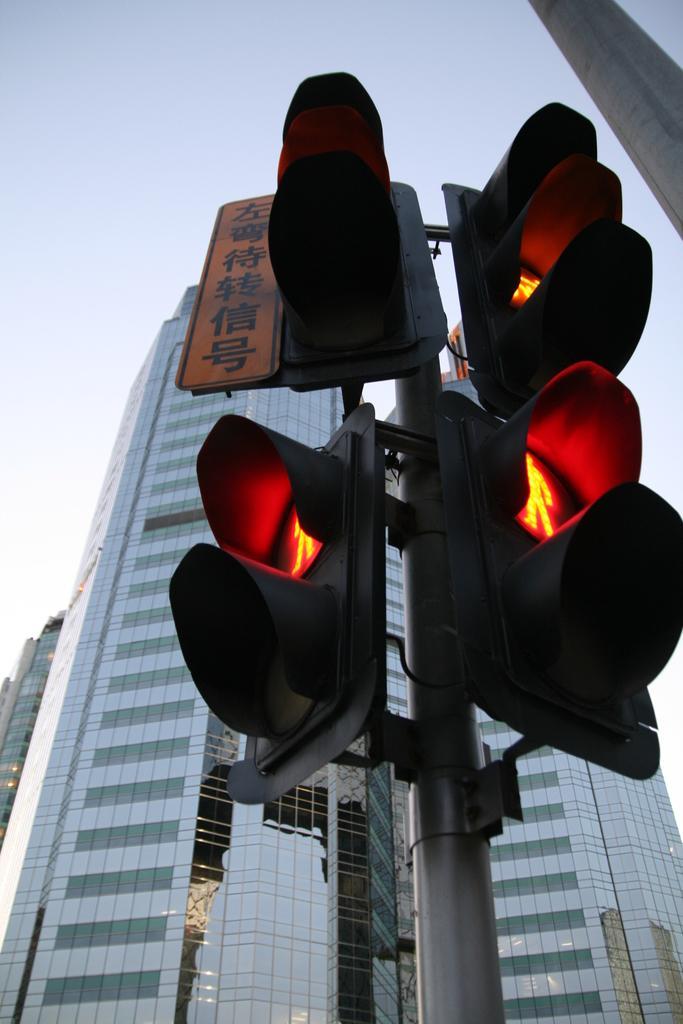Please provide a concise description of this image. In this picture we can see traffic signals, poles, buildings, board and in the background we can see the sky. 